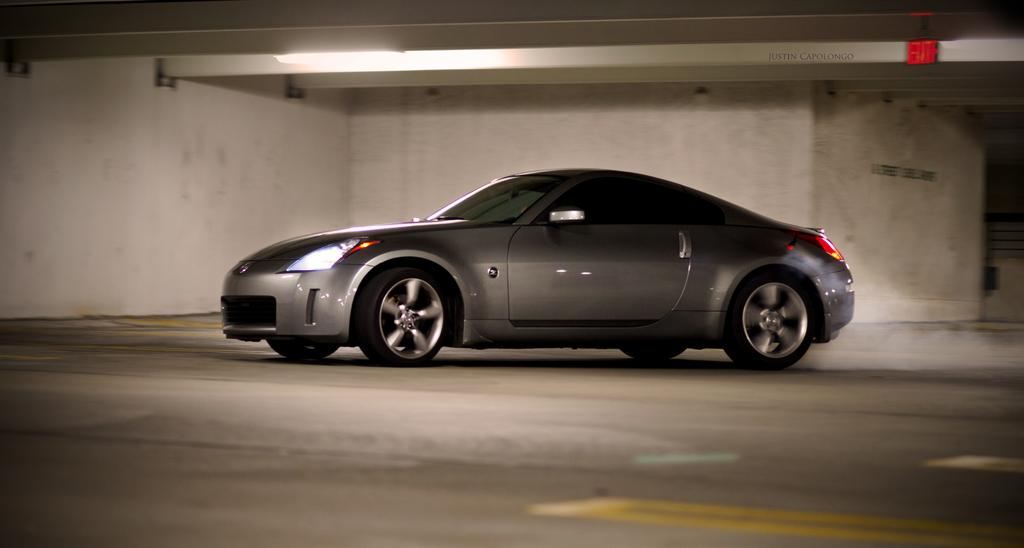What is the main subject of the image? There is a car in the image. Where is the car located? The car is on the road. What can be seen in the background of the image? There is a wall, a light, and a board visible in the background of the image. What type of scent can be detected coming from the car in the image? There is no information about the scent in the image, as it focuses on the visual aspects of the car and its surroundings. 